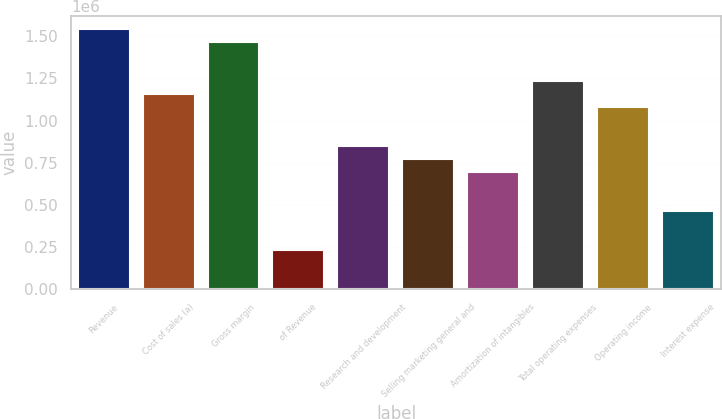<chart> <loc_0><loc_0><loc_500><loc_500><bar_chart><fcel>Revenue<fcel>Cost of sales (a)<fcel>Gross margin<fcel>of Revenue<fcel>Research and development<fcel>Selling marketing general and<fcel>Amortization of intangibles<fcel>Total operating expenses<fcel>Operating income<fcel>Interest expense<nl><fcel>1.54397e+06<fcel>1.15798e+06<fcel>1.46677e+06<fcel>231596<fcel>849185<fcel>771986<fcel>694787<fcel>1.23518e+06<fcel>1.08078e+06<fcel>463192<nl></chart> 